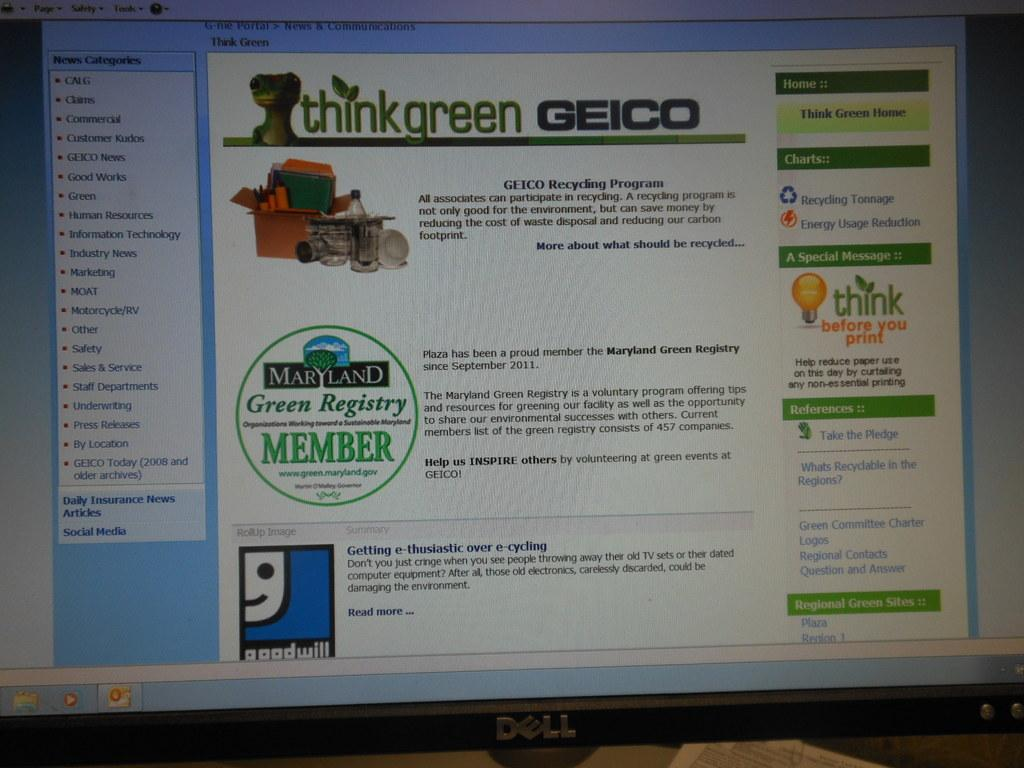<image>
Relay a brief, clear account of the picture shown. A dell monitor displaying think green geico on it. 